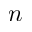<formula> <loc_0><loc_0><loc_500><loc_500>n</formula> 